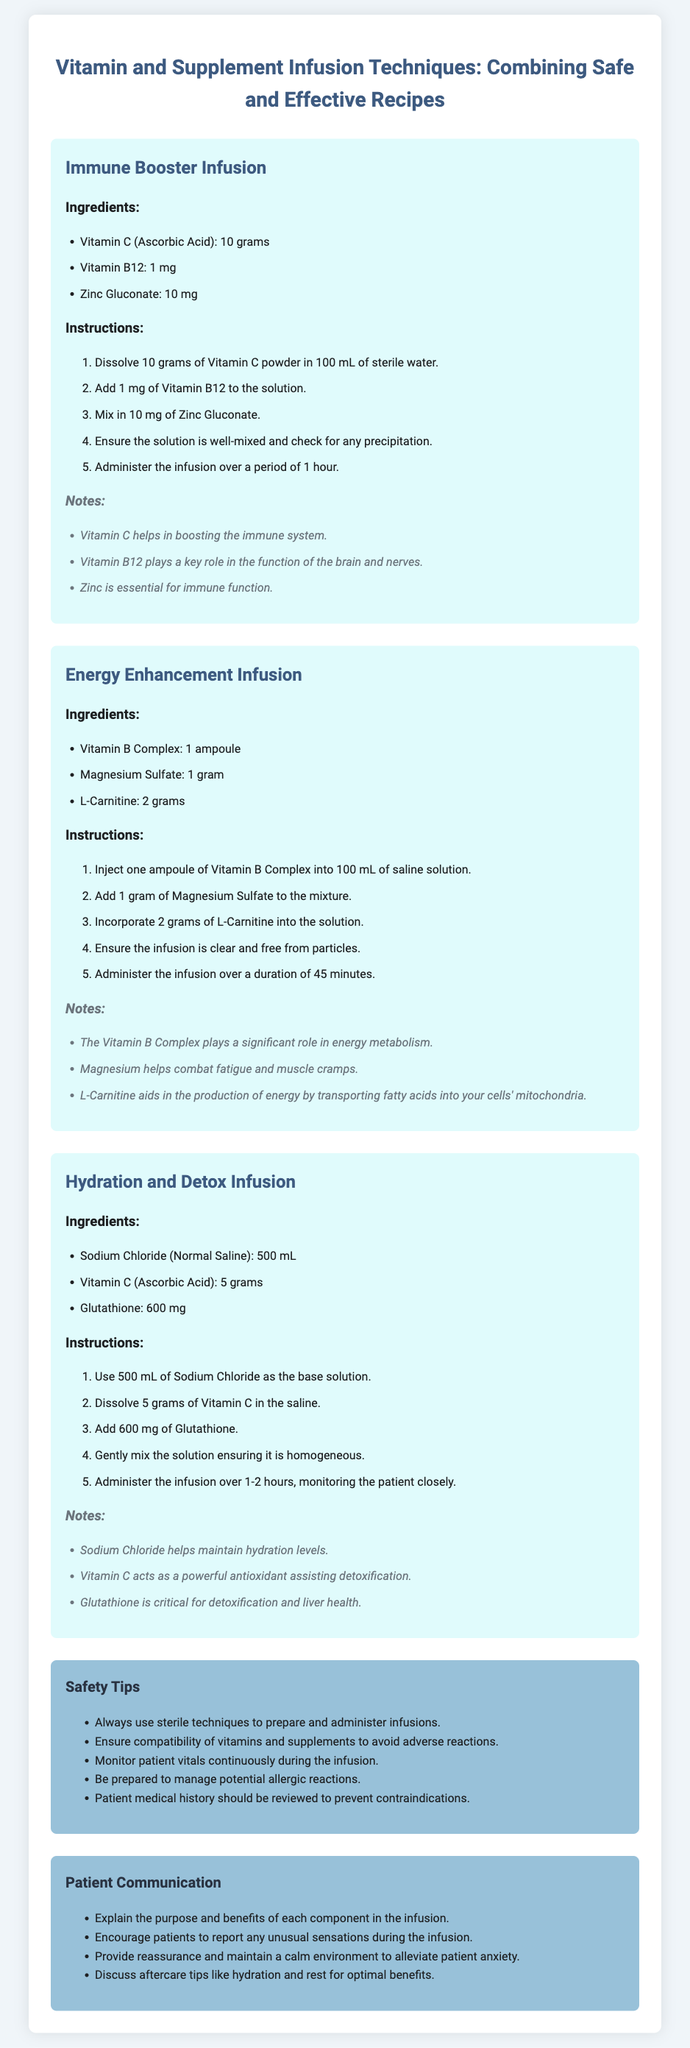What are the ingredients in the Immune Booster Infusion? The ingredients listed in the Immune Booster Infusion recipe include Vitamin C, Vitamin B12, and Zinc Gluconate.
Answer: Vitamin C, Vitamin B12, Zinc Gluconate How long should the Energy Enhancement Infusion be administered? The Energy Enhancement Infusion should be administered over a duration of 45 minutes, as specified in the instructions.
Answer: 45 minutes What is the total amount of Vitamin C used in both the Immune Booster and Hydration and Detox infusions? The Immune Booster uses 10 grams of Vitamin C, and the Hydration and Detox infusion uses 5 grams, totaling 15 grams.
Answer: 15 grams Which infusions contain Magnesium? The only infusion that includes Magnesium is the Energy Enhancement Infusion.
Answer: Energy Enhancement Infusion What role does Glutathione play in detoxification? The document notes that Glutathione is critical for detoxification and liver health, indicating its importance in this process.
Answer: Critical for detoxification What is a key safety tip for administering infusions? One key safety tip mentioned is to always use sterile techniques to prepare and administer infusions.
Answer: Use sterile techniques What should patients report during the infusion? Patients are encouraged to report any unusual sensations they experience during the infusion.
Answer: Unusual sensations How many grams of L-Carnitine are used in the Energy Enhancement Infusion? The recipe specifies that 2 grams of L-Carnitine are used in the Energy Enhancement Infusion.
Answer: 2 grams What should be ensured before administering the solutions? It is important to ensure that the solutions are clear and free from particles before administration.
Answer: Clear and free from particles 